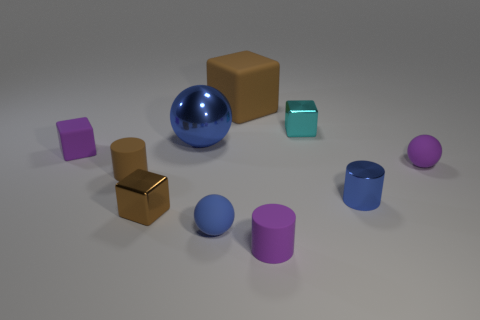How does the lighting affect the colors of the objects? The lighting in the image seems to be neutral and soft, causing minimal distortion of the objects' true colors. It enhances the visibility of their textures and shapes without creating harsh shadows. 